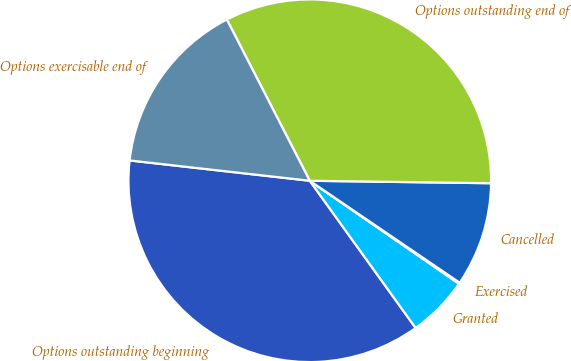Convert chart. <chart><loc_0><loc_0><loc_500><loc_500><pie_chart><fcel>Options outstanding beginning<fcel>Granted<fcel>Exercised<fcel>Cancelled<fcel>Options outstanding end of<fcel>Options exercisable end of<nl><fcel>36.71%<fcel>5.46%<fcel>0.11%<fcel>9.29%<fcel>32.78%<fcel>15.65%<nl></chart> 